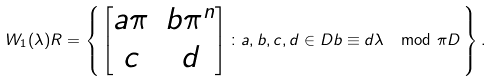<formula> <loc_0><loc_0><loc_500><loc_500>W _ { 1 } ( \lambda ) R = \left \{ \, \begin{bmatrix} a \pi & b \pi ^ { n } \\ c & d \end{bmatrix} \colon a , b , c , d \in D b \equiv d \lambda \mod \pi D \, \right \} .</formula> 